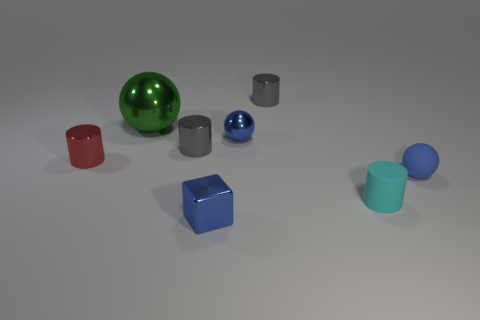Add 2 green balls. How many objects exist? 10 Subtract all small cyan cylinders. How many cylinders are left? 3 Subtract 0 brown spheres. How many objects are left? 8 Subtract all blocks. How many objects are left? 7 Subtract 3 balls. How many balls are left? 0 Subtract all purple cylinders. Subtract all blue blocks. How many cylinders are left? 4 Subtract all cyan cylinders. How many brown cubes are left? 0 Subtract all brown rubber things. Subtract all blue balls. How many objects are left? 6 Add 6 tiny blue rubber spheres. How many tiny blue rubber spheres are left? 7 Add 2 large green shiny balls. How many large green shiny balls exist? 3 